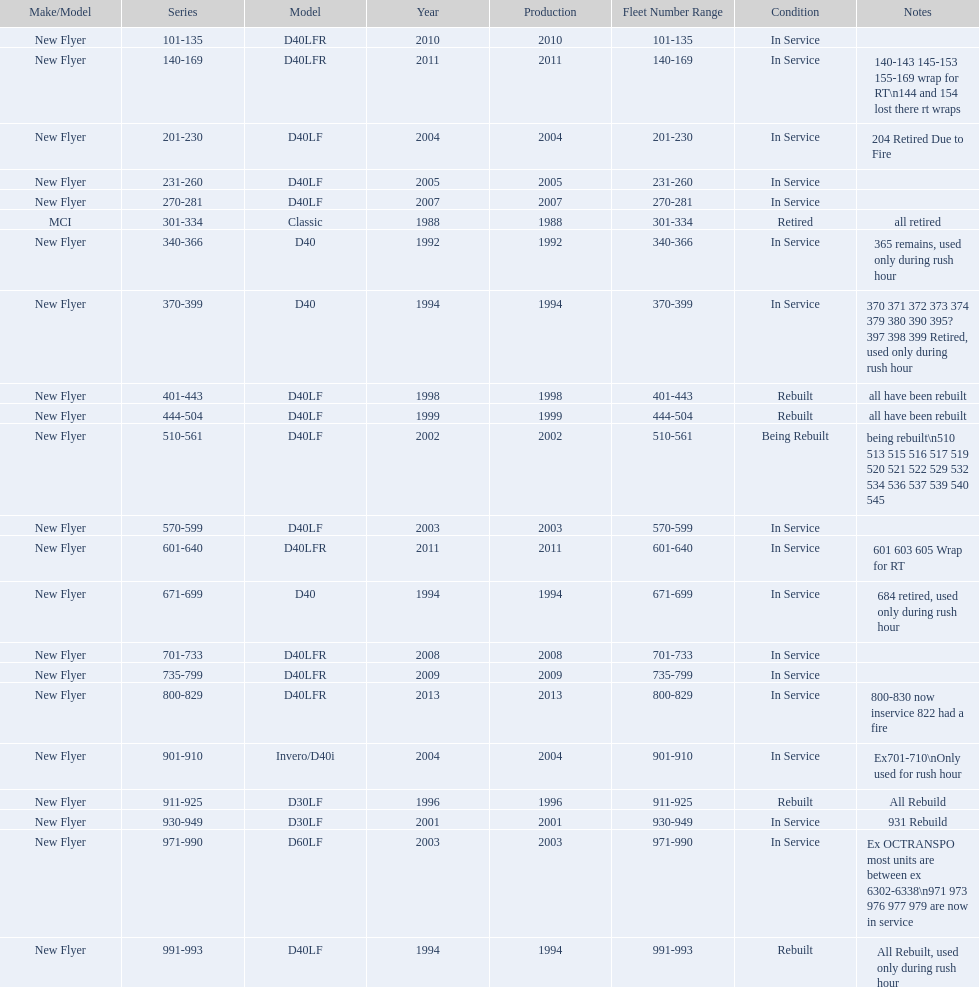What are all of the bus series numbers? 101-135, 140-169, 201-230, 231-260, 270-281, 301-334, 340-366, 370-399, 401-443, 444-504, 510-561, 570-599, 601-640, 671-699, 701-733, 735-799, 800-829, 901-910, 911-925, 930-949, 971-990, 991-993. When were they introduced? 2010, 2011, 2004, 2005, 2007, 1988, 1992, 1994, 1998, 1999, 2002, 2003, 2011, 1994, 2008, 2009, 2013, 2004, 1996, 2001, 2003, 1994. Which series is the newest? 800-829. 